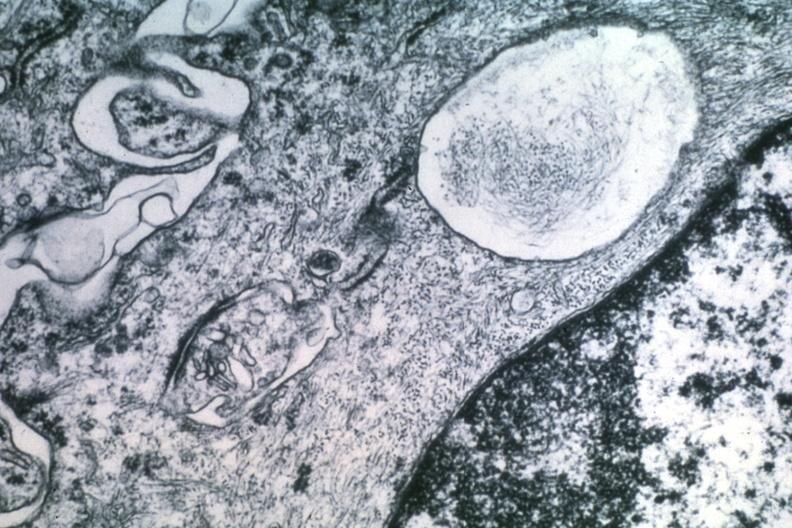what is present?
Answer the question using a single word or phrase. Brain 